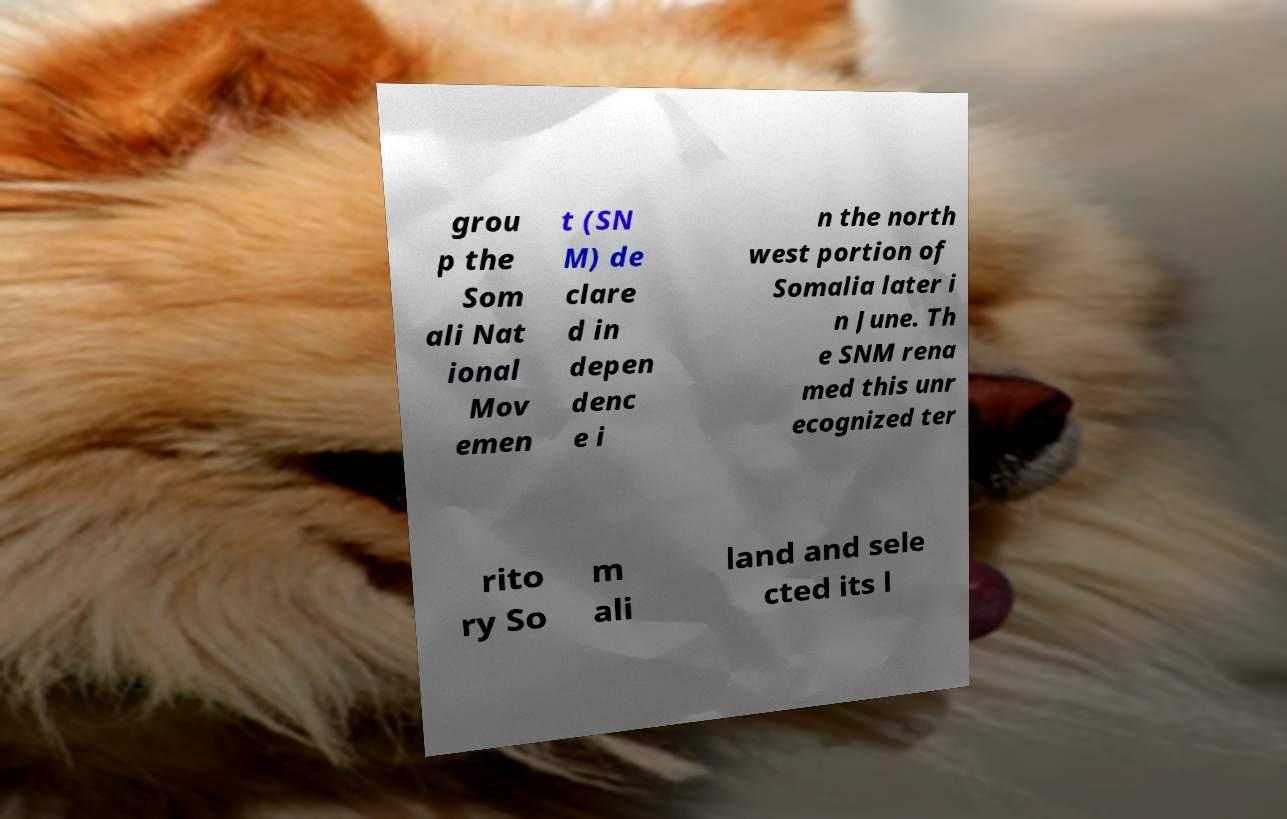Could you extract and type out the text from this image? grou p the Som ali Nat ional Mov emen t (SN M) de clare d in depen denc e i n the north west portion of Somalia later i n June. Th e SNM rena med this unr ecognized ter rito ry So m ali land and sele cted its l 